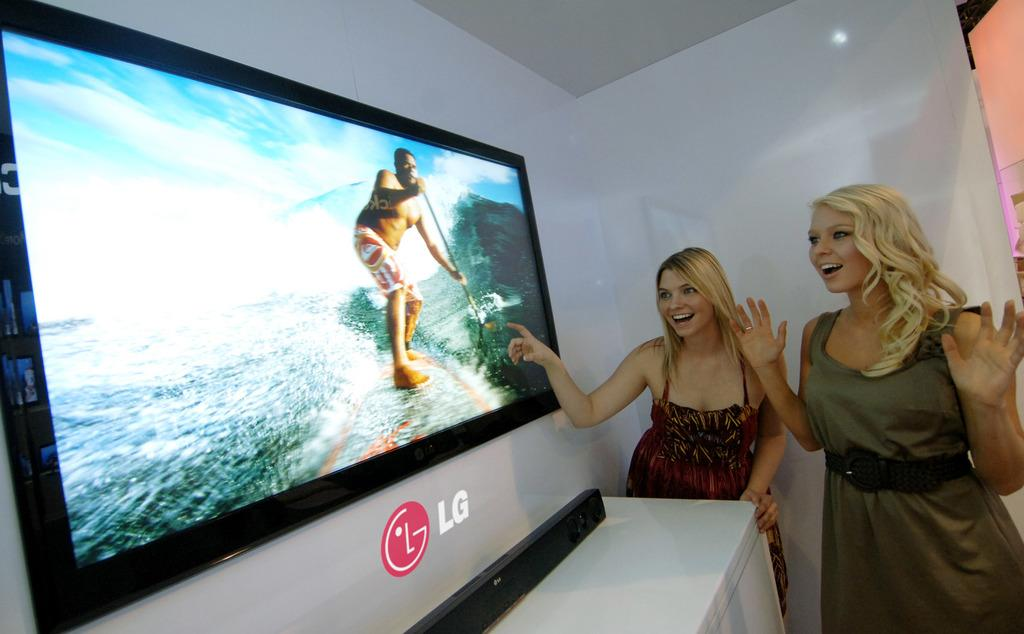<image>
Summarize the visual content of the image. an LG television that has a photo on it 